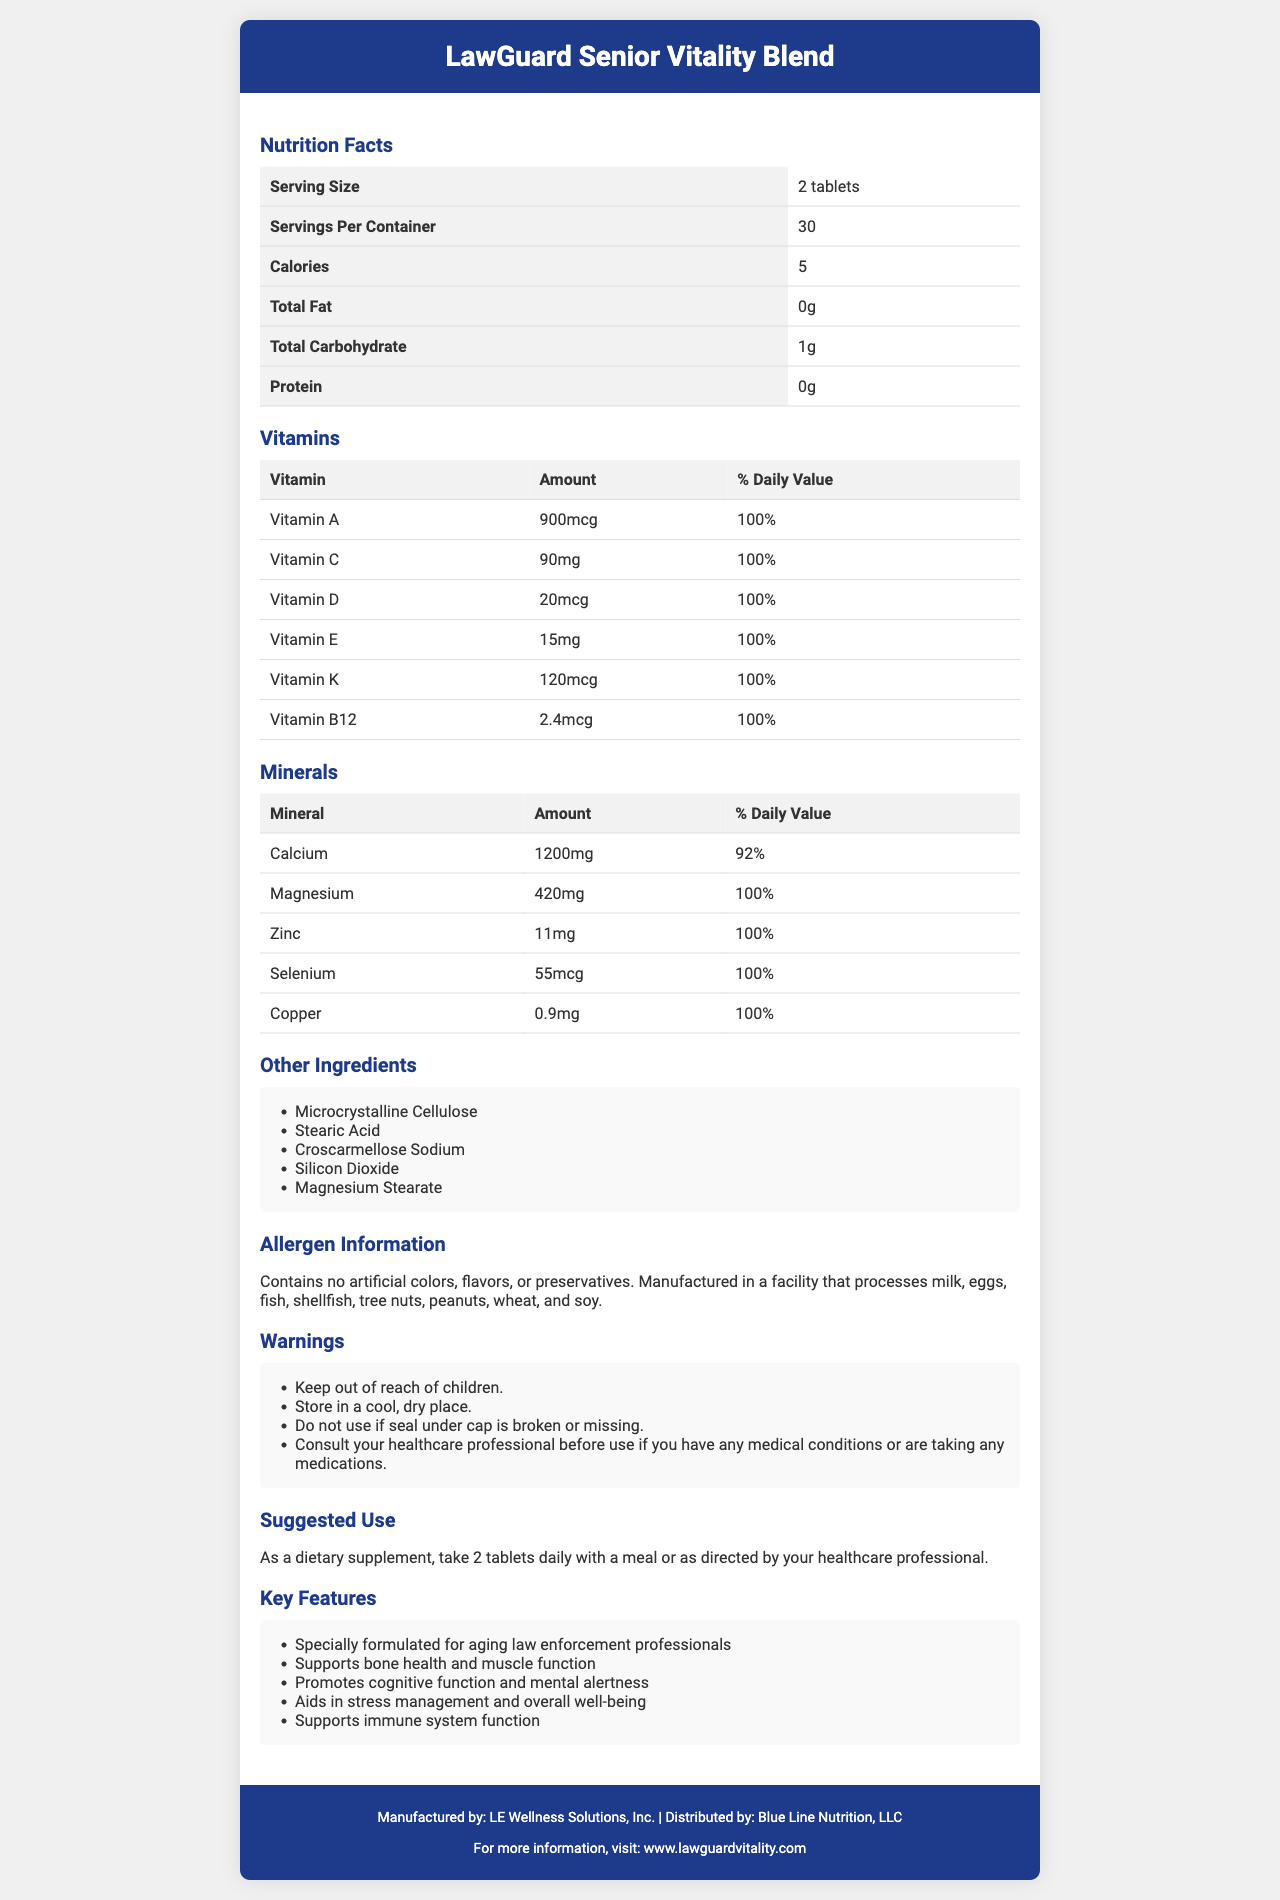which vitamins are included in the LawGuard Senior Vitality Blend? The section labeled "Vitamins" lists all the vitamins included, along with their amounts and daily values.
Answer: Vitamin A, Vitamin C, Vitamin D, Vitamin E, Vitamin K, Vitamin B12 what is the serving size for this supplement? The serving size is listed at the top of the Nutrition Facts section.
Answer: 2 tablets how many servings are there per container? The number of servings per container is listed right below the serving size.
Answer: 30 how many calories does each serving of the supplement contain? The calories per serving are listed under the serving size and servings per container.
Answer: 5 calories what is the suggested use for LawGuard Senior Vitality Blend? The suggested use section provides detailed instructions on how to take the supplement.
Answer: As a dietary supplement, take 2 tablets daily with a meal or as directed by your healthcare professional. which mineral has the highest daily value percentage? A. Zinc B. Calcium C. Magnesium D. Copper Magnesium has a daily value of 100%, the highest percentage among the minerals listed.
Answer: C. Magnesium which company distributes this product? A. LE Wellness Solutions, Inc. B. Blue Line Nutrition, LLC C. LawGuard Vitality Corp. D. Senior Health Solutions The footer section of the document lists Blue Line Nutrition, LLC as the distributor.
Answer: B. Blue Line Nutrition, LLC is this supplement suitable for children? The warning section states, "Keep out of reach of children," implying it is not suitable for children.
Answer: No summarize the main features of the LawGuard Senior Vitality Blend supplement The features section of the document highlights the main benefits and purposes of the supplement, targeting aging law enforcement professionals.
Answer: The LawGuard Senior Vitality Blend is specially formulated for aging law enforcement professionals. It supports bone health, muscle function, cognitive function, mental alertness, stress management, overall well-being, and immune system function. The product contains a variety of vitamins and minerals, has no artificial colors, flavors, or preservatives, and comes with specific usage and storage instructions. what is the amount of Vitamin D per serving? The amount of Vitamin D per serving is listed under the section "Vitamins."
Answer: 20mcg are there any artificial colors in this supplement? The allergen information section states that the product contains no artificial colors, flavors, or preservatives.
Answer: No what should you do if the seal under the cap is broken or missing? The warning section advises against using the product if the seal is compromised.
Answer: Do not use if the seal under the cap is broken or missing. does the document provide information on the manufacturing process of the vitamins and minerals? The document does not provide specific details on the manufacturing process of the vitamins and minerals, only general allergen information and manufacturing warnings.
Answer: Not enough information who manufactures LawGuard Senior Vitality Blend? The footer section lists LE Wellness Solutions, Inc. as the manufacturer of the product.
Answer: LE Wellness Solutions, Inc. 